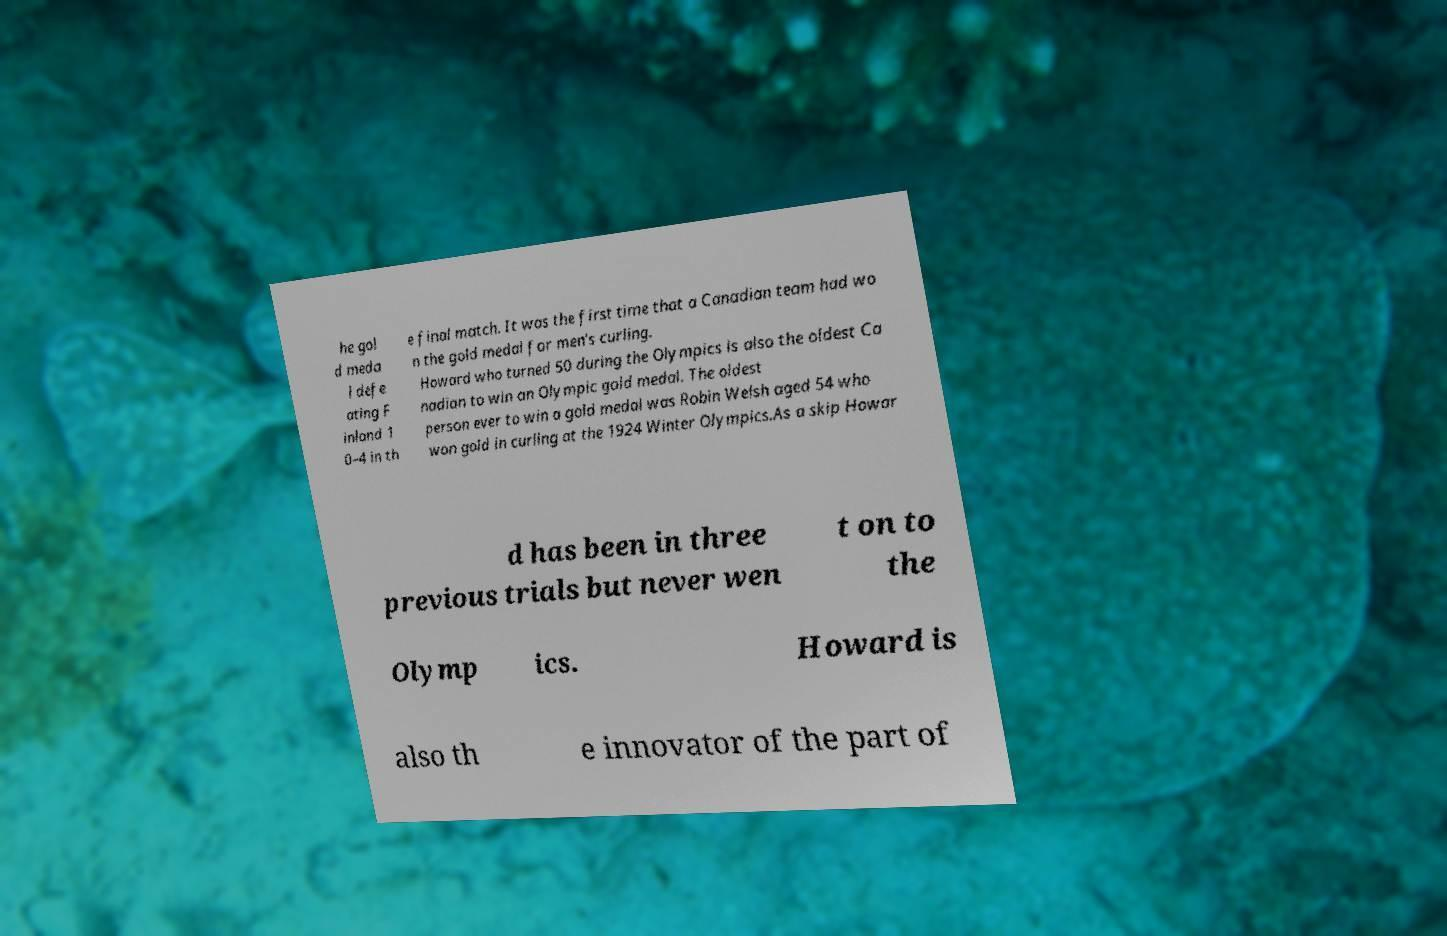There's text embedded in this image that I need extracted. Can you transcribe it verbatim? he gol d meda l defe ating F inland 1 0–4 in th e final match. It was the first time that a Canadian team had wo n the gold medal for men's curling. Howard who turned 50 during the Olympics is also the oldest Ca nadian to win an Olympic gold medal. The oldest person ever to win a gold medal was Robin Welsh aged 54 who won gold in curling at the 1924 Winter Olympics.As a skip Howar d has been in three previous trials but never wen t on to the Olymp ics. Howard is also th e innovator of the part of 